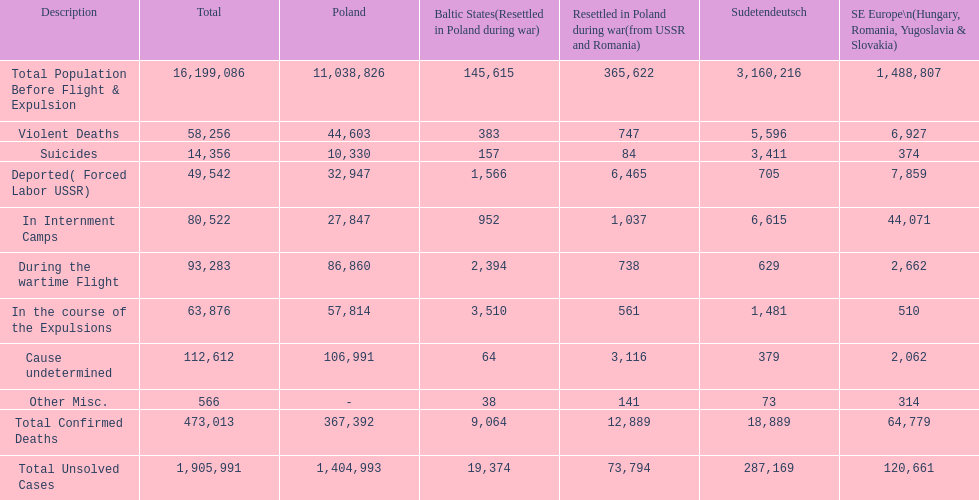What is the aggregate amount of violent deaths in every region? 58,256. 